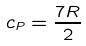Convert formula to latex. <formula><loc_0><loc_0><loc_500><loc_500>c _ { P } = \frac { 7 R } { 2 }</formula> 